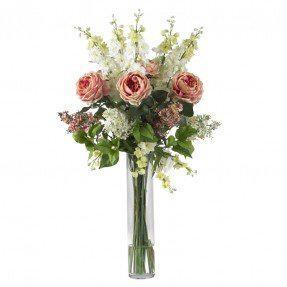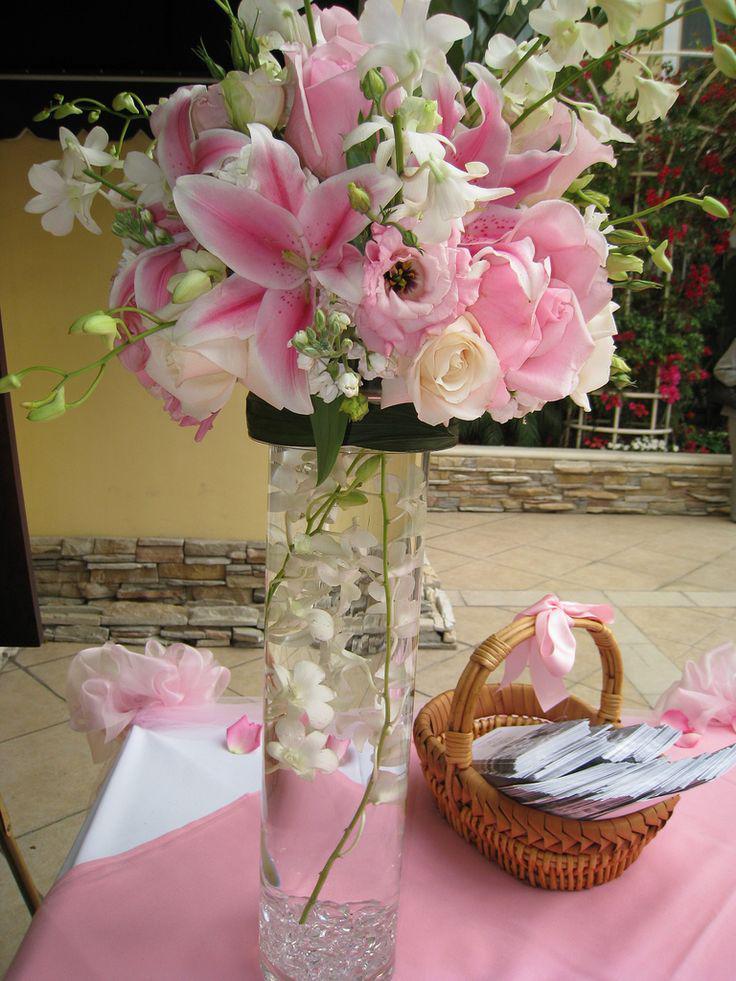The first image is the image on the left, the second image is the image on the right. Given the left and right images, does the statement "There are pink flowers in the vase in the image on the left." hold true? Answer yes or no. Yes. 